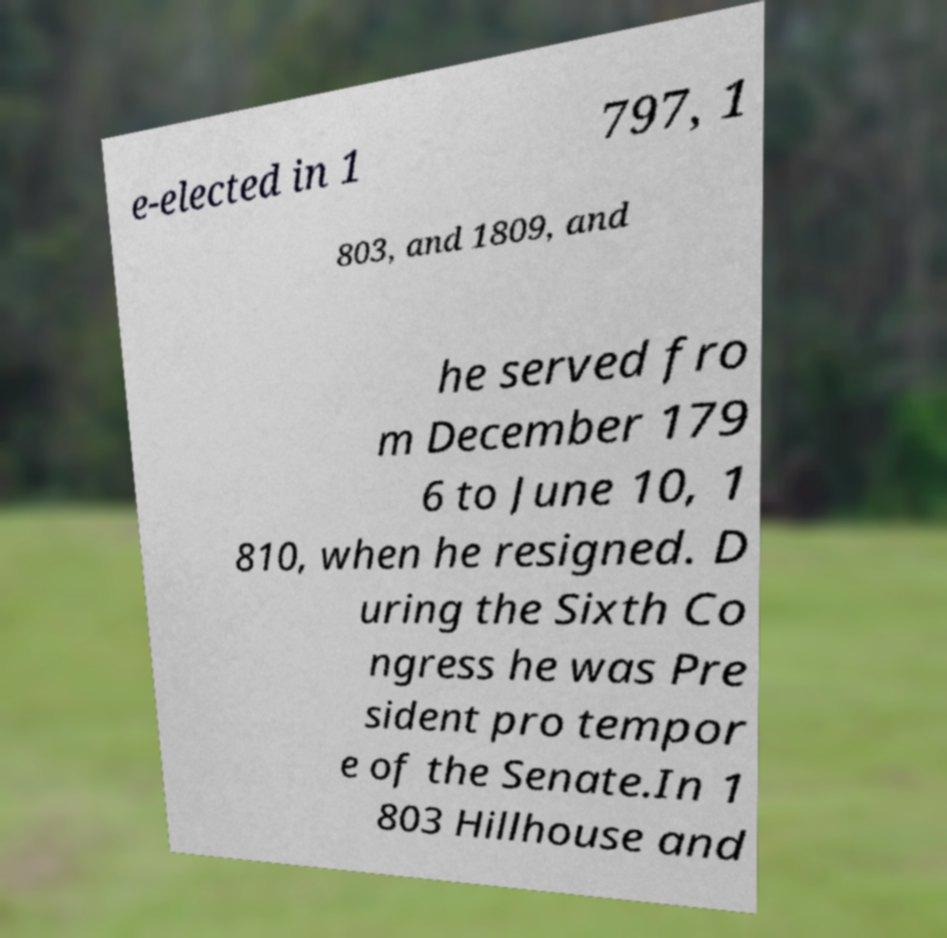Could you assist in decoding the text presented in this image and type it out clearly? e-elected in 1 797, 1 803, and 1809, and he served fro m December 179 6 to June 10, 1 810, when he resigned. D uring the Sixth Co ngress he was Pre sident pro tempor e of the Senate.In 1 803 Hillhouse and 